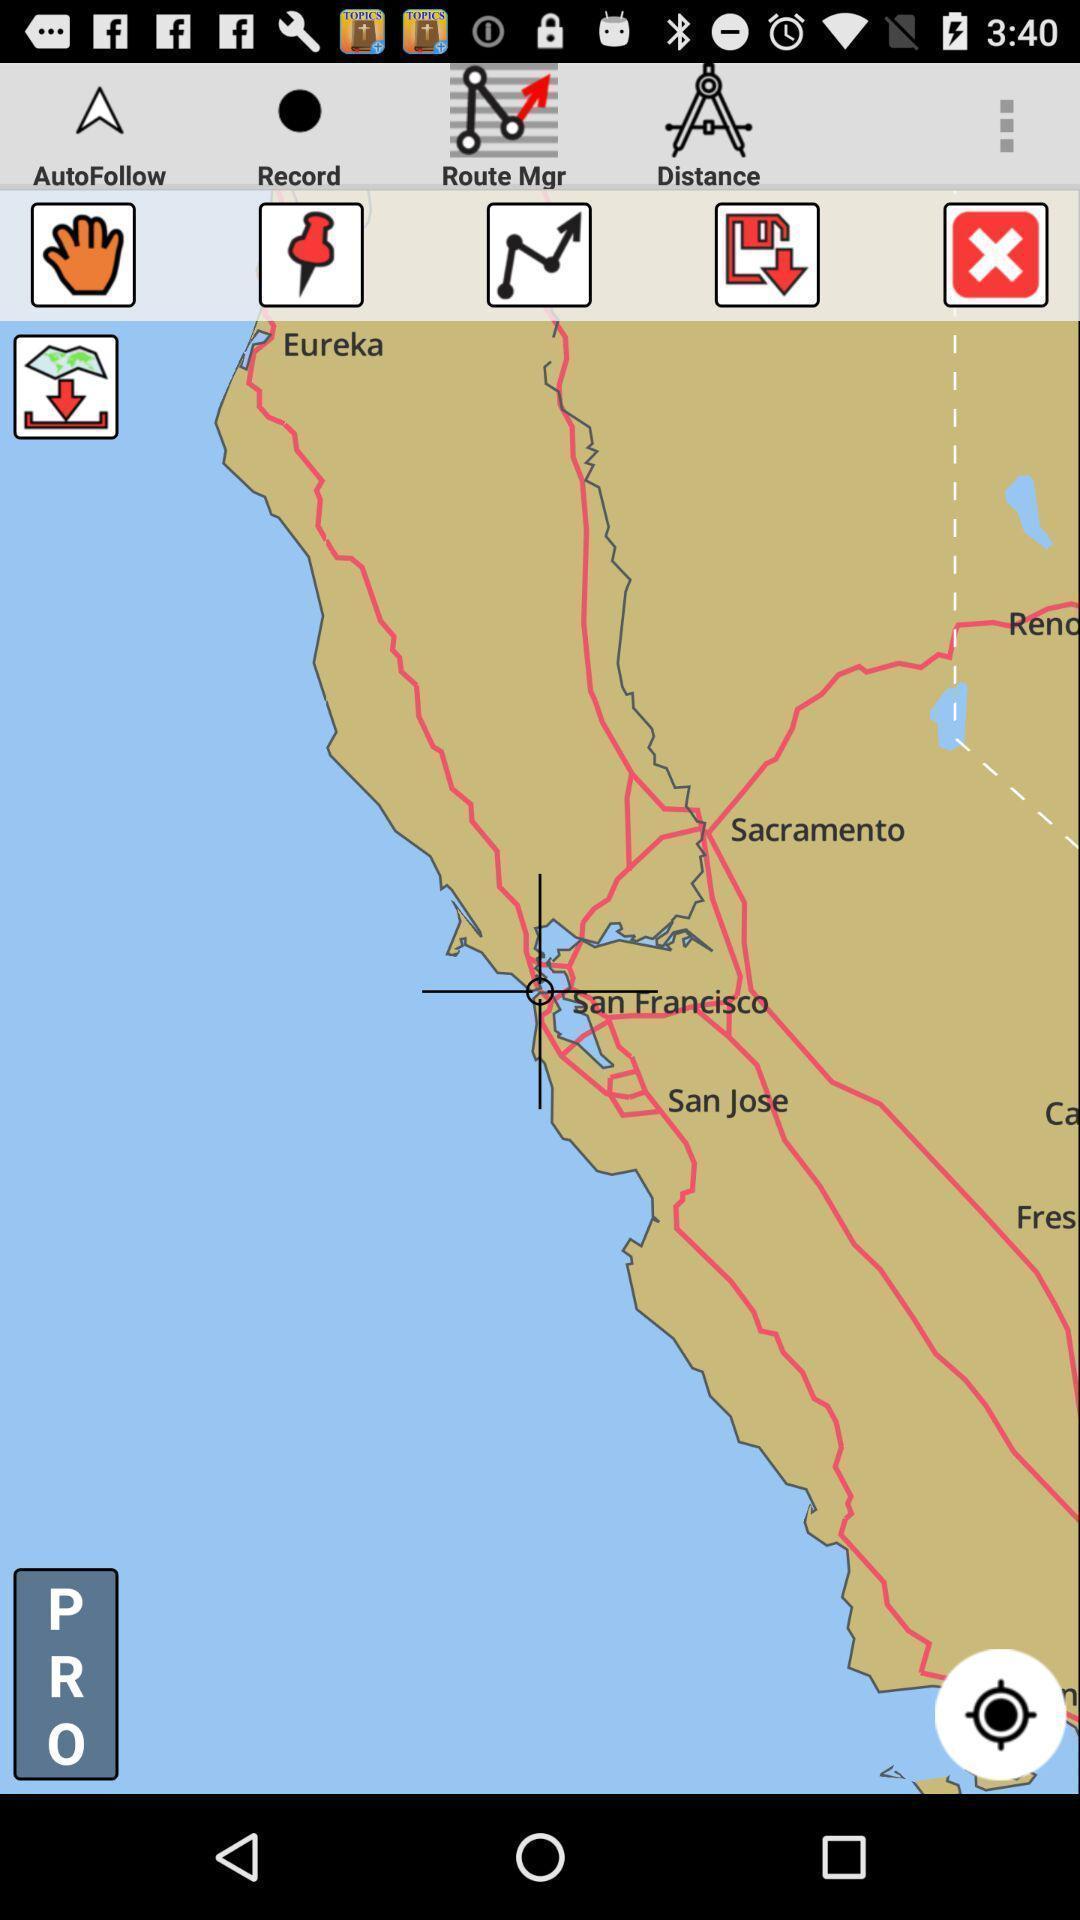Describe the content in this image. Screen displaying the navigation chart page. 